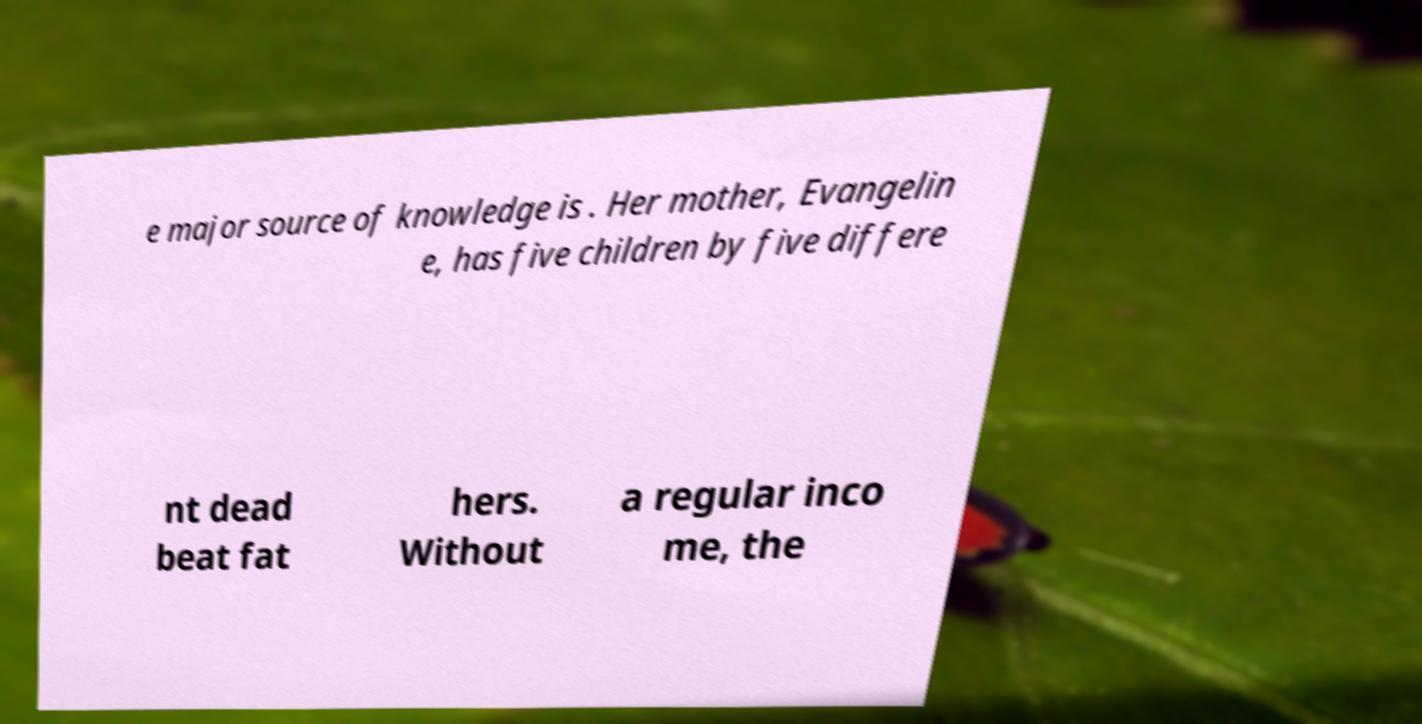Could you assist in decoding the text presented in this image and type it out clearly? e major source of knowledge is . Her mother, Evangelin e, has five children by five differe nt dead beat fat hers. Without a regular inco me, the 